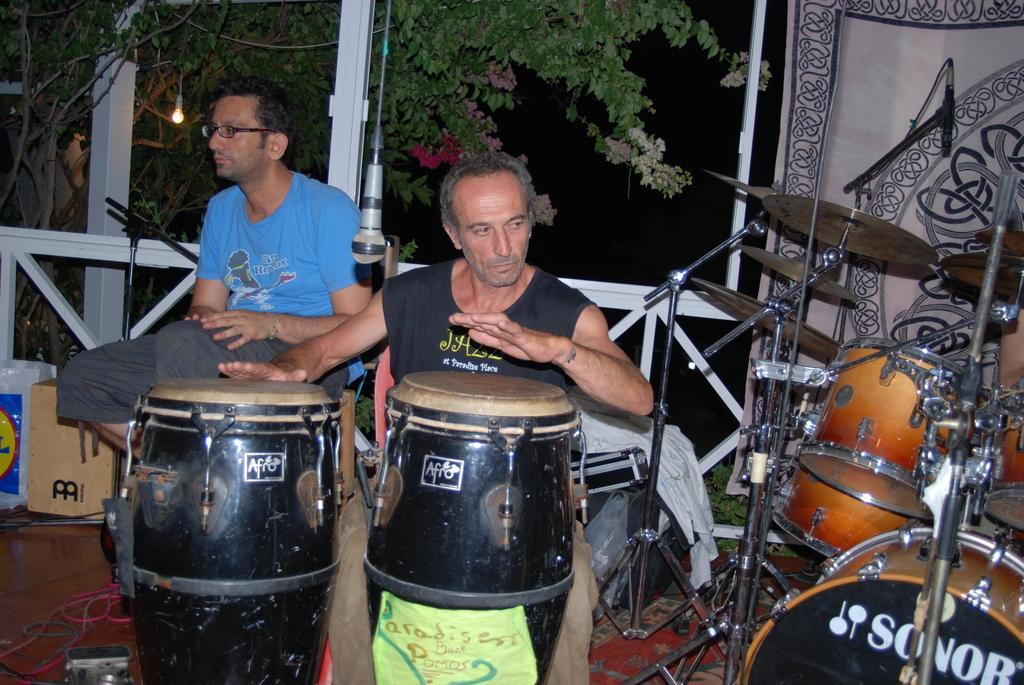How would you summarize this image in a sentence or two? In this image there is a man playing the drums, Beside him there is another man. At the top there is a mic which is hanged. On the right side there are drums,musical plates. On the left side there are boxes on the floor. In the background there is a tree to which there is a light. On the right side there is a curtain. 